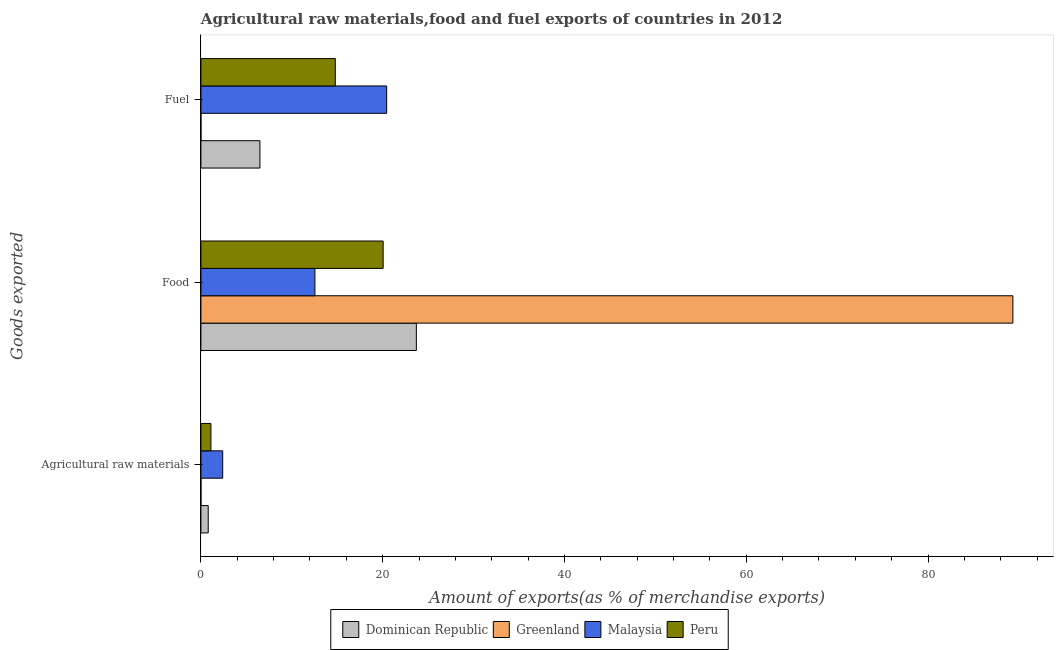How many groups of bars are there?
Keep it short and to the point. 3. Are the number of bars on each tick of the Y-axis equal?
Provide a short and direct response. Yes. How many bars are there on the 3rd tick from the top?
Ensure brevity in your answer.  4. What is the label of the 2nd group of bars from the top?
Your answer should be compact. Food. What is the percentage of fuel exports in Greenland?
Keep it short and to the point. 0. Across all countries, what is the maximum percentage of fuel exports?
Ensure brevity in your answer.  20.44. Across all countries, what is the minimum percentage of fuel exports?
Make the answer very short. 0. In which country was the percentage of fuel exports maximum?
Your response must be concise. Malaysia. In which country was the percentage of raw materials exports minimum?
Your answer should be very brief. Greenland. What is the total percentage of food exports in the graph?
Provide a succinct answer. 145.63. What is the difference between the percentage of fuel exports in Peru and that in Greenland?
Give a very brief answer. 14.79. What is the difference between the percentage of fuel exports in Peru and the percentage of raw materials exports in Malaysia?
Offer a very short reply. 12.39. What is the average percentage of raw materials exports per country?
Your answer should be very brief. 1.07. What is the difference between the percentage of raw materials exports and percentage of fuel exports in Greenland?
Provide a short and direct response. 0. In how many countries, is the percentage of food exports greater than 80 %?
Offer a very short reply. 1. What is the ratio of the percentage of fuel exports in Dominican Republic to that in Malaysia?
Keep it short and to the point. 0.32. What is the difference between the highest and the second highest percentage of fuel exports?
Provide a succinct answer. 5.65. What is the difference between the highest and the lowest percentage of fuel exports?
Your answer should be compact. 20.44. Is the sum of the percentage of fuel exports in Malaysia and Dominican Republic greater than the maximum percentage of food exports across all countries?
Offer a terse response. No. What does the 4th bar from the top in Agricultural raw materials represents?
Ensure brevity in your answer.  Dominican Republic. Is it the case that in every country, the sum of the percentage of raw materials exports and percentage of food exports is greater than the percentage of fuel exports?
Make the answer very short. No. How many bars are there?
Provide a succinct answer. 12. Are all the bars in the graph horizontal?
Your answer should be very brief. Yes. How many countries are there in the graph?
Offer a very short reply. 4. What is the difference between two consecutive major ticks on the X-axis?
Provide a short and direct response. 20. How many legend labels are there?
Offer a terse response. 4. How are the legend labels stacked?
Offer a terse response. Horizontal. What is the title of the graph?
Your response must be concise. Agricultural raw materials,food and fuel exports of countries in 2012. Does "China" appear as one of the legend labels in the graph?
Offer a very short reply. No. What is the label or title of the X-axis?
Provide a short and direct response. Amount of exports(as % of merchandise exports). What is the label or title of the Y-axis?
Make the answer very short. Goods exported. What is the Amount of exports(as % of merchandise exports) in Dominican Republic in Agricultural raw materials?
Give a very brief answer. 0.8. What is the Amount of exports(as % of merchandise exports) in Greenland in Agricultural raw materials?
Your response must be concise. 0. What is the Amount of exports(as % of merchandise exports) in Malaysia in Agricultural raw materials?
Ensure brevity in your answer.  2.4. What is the Amount of exports(as % of merchandise exports) in Peru in Agricultural raw materials?
Your answer should be very brief. 1.1. What is the Amount of exports(as % of merchandise exports) of Dominican Republic in Food?
Give a very brief answer. 23.7. What is the Amount of exports(as % of merchandise exports) of Greenland in Food?
Make the answer very short. 89.34. What is the Amount of exports(as % of merchandise exports) of Malaysia in Food?
Offer a very short reply. 12.54. What is the Amount of exports(as % of merchandise exports) in Peru in Food?
Keep it short and to the point. 20.05. What is the Amount of exports(as % of merchandise exports) of Dominican Republic in Fuel?
Offer a very short reply. 6.49. What is the Amount of exports(as % of merchandise exports) of Greenland in Fuel?
Give a very brief answer. 0. What is the Amount of exports(as % of merchandise exports) of Malaysia in Fuel?
Offer a very short reply. 20.44. What is the Amount of exports(as % of merchandise exports) of Peru in Fuel?
Your response must be concise. 14.79. Across all Goods exported, what is the maximum Amount of exports(as % of merchandise exports) of Dominican Republic?
Offer a terse response. 23.7. Across all Goods exported, what is the maximum Amount of exports(as % of merchandise exports) of Greenland?
Give a very brief answer. 89.34. Across all Goods exported, what is the maximum Amount of exports(as % of merchandise exports) of Malaysia?
Provide a short and direct response. 20.44. Across all Goods exported, what is the maximum Amount of exports(as % of merchandise exports) in Peru?
Provide a short and direct response. 20.05. Across all Goods exported, what is the minimum Amount of exports(as % of merchandise exports) of Dominican Republic?
Your answer should be compact. 0.8. Across all Goods exported, what is the minimum Amount of exports(as % of merchandise exports) of Greenland?
Your response must be concise. 0. Across all Goods exported, what is the minimum Amount of exports(as % of merchandise exports) in Malaysia?
Your response must be concise. 2.4. Across all Goods exported, what is the minimum Amount of exports(as % of merchandise exports) in Peru?
Offer a terse response. 1.1. What is the total Amount of exports(as % of merchandise exports) of Dominican Republic in the graph?
Provide a succinct answer. 31. What is the total Amount of exports(as % of merchandise exports) of Greenland in the graph?
Your answer should be compact. 89.34. What is the total Amount of exports(as % of merchandise exports) of Malaysia in the graph?
Ensure brevity in your answer.  35.37. What is the total Amount of exports(as % of merchandise exports) of Peru in the graph?
Give a very brief answer. 35.93. What is the difference between the Amount of exports(as % of merchandise exports) in Dominican Republic in Agricultural raw materials and that in Food?
Your answer should be very brief. -22.9. What is the difference between the Amount of exports(as % of merchandise exports) of Greenland in Agricultural raw materials and that in Food?
Offer a terse response. -89.34. What is the difference between the Amount of exports(as % of merchandise exports) in Malaysia in Agricultural raw materials and that in Food?
Offer a very short reply. -10.14. What is the difference between the Amount of exports(as % of merchandise exports) in Peru in Agricultural raw materials and that in Food?
Your response must be concise. -18.95. What is the difference between the Amount of exports(as % of merchandise exports) in Dominican Republic in Agricultural raw materials and that in Fuel?
Make the answer very short. -5.69. What is the difference between the Amount of exports(as % of merchandise exports) in Malaysia in Agricultural raw materials and that in Fuel?
Your response must be concise. -18.04. What is the difference between the Amount of exports(as % of merchandise exports) of Peru in Agricultural raw materials and that in Fuel?
Keep it short and to the point. -13.69. What is the difference between the Amount of exports(as % of merchandise exports) in Dominican Republic in Food and that in Fuel?
Give a very brief answer. 17.21. What is the difference between the Amount of exports(as % of merchandise exports) in Greenland in Food and that in Fuel?
Your answer should be compact. 89.34. What is the difference between the Amount of exports(as % of merchandise exports) of Malaysia in Food and that in Fuel?
Make the answer very short. -7.9. What is the difference between the Amount of exports(as % of merchandise exports) in Peru in Food and that in Fuel?
Your response must be concise. 5.26. What is the difference between the Amount of exports(as % of merchandise exports) of Dominican Republic in Agricultural raw materials and the Amount of exports(as % of merchandise exports) of Greenland in Food?
Make the answer very short. -88.53. What is the difference between the Amount of exports(as % of merchandise exports) of Dominican Republic in Agricultural raw materials and the Amount of exports(as % of merchandise exports) of Malaysia in Food?
Make the answer very short. -11.74. What is the difference between the Amount of exports(as % of merchandise exports) of Dominican Republic in Agricultural raw materials and the Amount of exports(as % of merchandise exports) of Peru in Food?
Make the answer very short. -19.25. What is the difference between the Amount of exports(as % of merchandise exports) of Greenland in Agricultural raw materials and the Amount of exports(as % of merchandise exports) of Malaysia in Food?
Ensure brevity in your answer.  -12.54. What is the difference between the Amount of exports(as % of merchandise exports) of Greenland in Agricultural raw materials and the Amount of exports(as % of merchandise exports) of Peru in Food?
Keep it short and to the point. -20.05. What is the difference between the Amount of exports(as % of merchandise exports) in Malaysia in Agricultural raw materials and the Amount of exports(as % of merchandise exports) in Peru in Food?
Offer a terse response. -17.65. What is the difference between the Amount of exports(as % of merchandise exports) in Dominican Republic in Agricultural raw materials and the Amount of exports(as % of merchandise exports) in Greenland in Fuel?
Offer a very short reply. 0.8. What is the difference between the Amount of exports(as % of merchandise exports) in Dominican Republic in Agricultural raw materials and the Amount of exports(as % of merchandise exports) in Malaysia in Fuel?
Provide a succinct answer. -19.63. What is the difference between the Amount of exports(as % of merchandise exports) of Dominican Republic in Agricultural raw materials and the Amount of exports(as % of merchandise exports) of Peru in Fuel?
Your response must be concise. -13.99. What is the difference between the Amount of exports(as % of merchandise exports) in Greenland in Agricultural raw materials and the Amount of exports(as % of merchandise exports) in Malaysia in Fuel?
Keep it short and to the point. -20.44. What is the difference between the Amount of exports(as % of merchandise exports) of Greenland in Agricultural raw materials and the Amount of exports(as % of merchandise exports) of Peru in Fuel?
Provide a short and direct response. -14.79. What is the difference between the Amount of exports(as % of merchandise exports) in Malaysia in Agricultural raw materials and the Amount of exports(as % of merchandise exports) in Peru in Fuel?
Provide a succinct answer. -12.39. What is the difference between the Amount of exports(as % of merchandise exports) in Dominican Republic in Food and the Amount of exports(as % of merchandise exports) in Greenland in Fuel?
Keep it short and to the point. 23.7. What is the difference between the Amount of exports(as % of merchandise exports) of Dominican Republic in Food and the Amount of exports(as % of merchandise exports) of Malaysia in Fuel?
Give a very brief answer. 3.27. What is the difference between the Amount of exports(as % of merchandise exports) of Dominican Republic in Food and the Amount of exports(as % of merchandise exports) of Peru in Fuel?
Your answer should be very brief. 8.92. What is the difference between the Amount of exports(as % of merchandise exports) of Greenland in Food and the Amount of exports(as % of merchandise exports) of Malaysia in Fuel?
Your response must be concise. 68.9. What is the difference between the Amount of exports(as % of merchandise exports) of Greenland in Food and the Amount of exports(as % of merchandise exports) of Peru in Fuel?
Make the answer very short. 74.55. What is the difference between the Amount of exports(as % of merchandise exports) of Malaysia in Food and the Amount of exports(as % of merchandise exports) of Peru in Fuel?
Your response must be concise. -2.25. What is the average Amount of exports(as % of merchandise exports) of Dominican Republic per Goods exported?
Your answer should be compact. 10.33. What is the average Amount of exports(as % of merchandise exports) of Greenland per Goods exported?
Give a very brief answer. 29.78. What is the average Amount of exports(as % of merchandise exports) in Malaysia per Goods exported?
Keep it short and to the point. 11.79. What is the average Amount of exports(as % of merchandise exports) in Peru per Goods exported?
Make the answer very short. 11.98. What is the difference between the Amount of exports(as % of merchandise exports) of Dominican Republic and Amount of exports(as % of merchandise exports) of Greenland in Agricultural raw materials?
Offer a very short reply. 0.8. What is the difference between the Amount of exports(as % of merchandise exports) of Dominican Republic and Amount of exports(as % of merchandise exports) of Malaysia in Agricultural raw materials?
Your response must be concise. -1.59. What is the difference between the Amount of exports(as % of merchandise exports) in Dominican Republic and Amount of exports(as % of merchandise exports) in Peru in Agricultural raw materials?
Ensure brevity in your answer.  -0.3. What is the difference between the Amount of exports(as % of merchandise exports) in Greenland and Amount of exports(as % of merchandise exports) in Malaysia in Agricultural raw materials?
Provide a succinct answer. -2.4. What is the difference between the Amount of exports(as % of merchandise exports) of Greenland and Amount of exports(as % of merchandise exports) of Peru in Agricultural raw materials?
Give a very brief answer. -1.1. What is the difference between the Amount of exports(as % of merchandise exports) in Malaysia and Amount of exports(as % of merchandise exports) in Peru in Agricultural raw materials?
Make the answer very short. 1.3. What is the difference between the Amount of exports(as % of merchandise exports) of Dominican Republic and Amount of exports(as % of merchandise exports) of Greenland in Food?
Provide a succinct answer. -65.63. What is the difference between the Amount of exports(as % of merchandise exports) of Dominican Republic and Amount of exports(as % of merchandise exports) of Malaysia in Food?
Offer a terse response. 11.16. What is the difference between the Amount of exports(as % of merchandise exports) in Dominican Republic and Amount of exports(as % of merchandise exports) in Peru in Food?
Keep it short and to the point. 3.66. What is the difference between the Amount of exports(as % of merchandise exports) of Greenland and Amount of exports(as % of merchandise exports) of Malaysia in Food?
Your response must be concise. 76.8. What is the difference between the Amount of exports(as % of merchandise exports) of Greenland and Amount of exports(as % of merchandise exports) of Peru in Food?
Provide a short and direct response. 69.29. What is the difference between the Amount of exports(as % of merchandise exports) in Malaysia and Amount of exports(as % of merchandise exports) in Peru in Food?
Your response must be concise. -7.51. What is the difference between the Amount of exports(as % of merchandise exports) in Dominican Republic and Amount of exports(as % of merchandise exports) in Greenland in Fuel?
Offer a terse response. 6.49. What is the difference between the Amount of exports(as % of merchandise exports) of Dominican Republic and Amount of exports(as % of merchandise exports) of Malaysia in Fuel?
Ensure brevity in your answer.  -13.94. What is the difference between the Amount of exports(as % of merchandise exports) in Dominican Republic and Amount of exports(as % of merchandise exports) in Peru in Fuel?
Offer a terse response. -8.3. What is the difference between the Amount of exports(as % of merchandise exports) in Greenland and Amount of exports(as % of merchandise exports) in Malaysia in Fuel?
Your answer should be very brief. -20.44. What is the difference between the Amount of exports(as % of merchandise exports) of Greenland and Amount of exports(as % of merchandise exports) of Peru in Fuel?
Your answer should be very brief. -14.79. What is the difference between the Amount of exports(as % of merchandise exports) in Malaysia and Amount of exports(as % of merchandise exports) in Peru in Fuel?
Your answer should be compact. 5.65. What is the ratio of the Amount of exports(as % of merchandise exports) in Dominican Republic in Agricultural raw materials to that in Food?
Give a very brief answer. 0.03. What is the ratio of the Amount of exports(as % of merchandise exports) of Malaysia in Agricultural raw materials to that in Food?
Your answer should be compact. 0.19. What is the ratio of the Amount of exports(as % of merchandise exports) of Peru in Agricultural raw materials to that in Food?
Offer a very short reply. 0.05. What is the ratio of the Amount of exports(as % of merchandise exports) in Dominican Republic in Agricultural raw materials to that in Fuel?
Provide a succinct answer. 0.12. What is the ratio of the Amount of exports(as % of merchandise exports) in Greenland in Agricultural raw materials to that in Fuel?
Provide a succinct answer. 4.29. What is the ratio of the Amount of exports(as % of merchandise exports) of Malaysia in Agricultural raw materials to that in Fuel?
Offer a terse response. 0.12. What is the ratio of the Amount of exports(as % of merchandise exports) in Peru in Agricultural raw materials to that in Fuel?
Offer a terse response. 0.07. What is the ratio of the Amount of exports(as % of merchandise exports) in Dominican Republic in Food to that in Fuel?
Provide a succinct answer. 3.65. What is the ratio of the Amount of exports(as % of merchandise exports) of Greenland in Food to that in Fuel?
Offer a terse response. 7.17e+05. What is the ratio of the Amount of exports(as % of merchandise exports) of Malaysia in Food to that in Fuel?
Keep it short and to the point. 0.61. What is the ratio of the Amount of exports(as % of merchandise exports) of Peru in Food to that in Fuel?
Give a very brief answer. 1.36. What is the difference between the highest and the second highest Amount of exports(as % of merchandise exports) of Dominican Republic?
Offer a terse response. 17.21. What is the difference between the highest and the second highest Amount of exports(as % of merchandise exports) in Greenland?
Make the answer very short. 89.34. What is the difference between the highest and the second highest Amount of exports(as % of merchandise exports) in Malaysia?
Provide a succinct answer. 7.9. What is the difference between the highest and the second highest Amount of exports(as % of merchandise exports) of Peru?
Ensure brevity in your answer.  5.26. What is the difference between the highest and the lowest Amount of exports(as % of merchandise exports) in Dominican Republic?
Your response must be concise. 22.9. What is the difference between the highest and the lowest Amount of exports(as % of merchandise exports) in Greenland?
Offer a terse response. 89.34. What is the difference between the highest and the lowest Amount of exports(as % of merchandise exports) in Malaysia?
Keep it short and to the point. 18.04. What is the difference between the highest and the lowest Amount of exports(as % of merchandise exports) in Peru?
Ensure brevity in your answer.  18.95. 